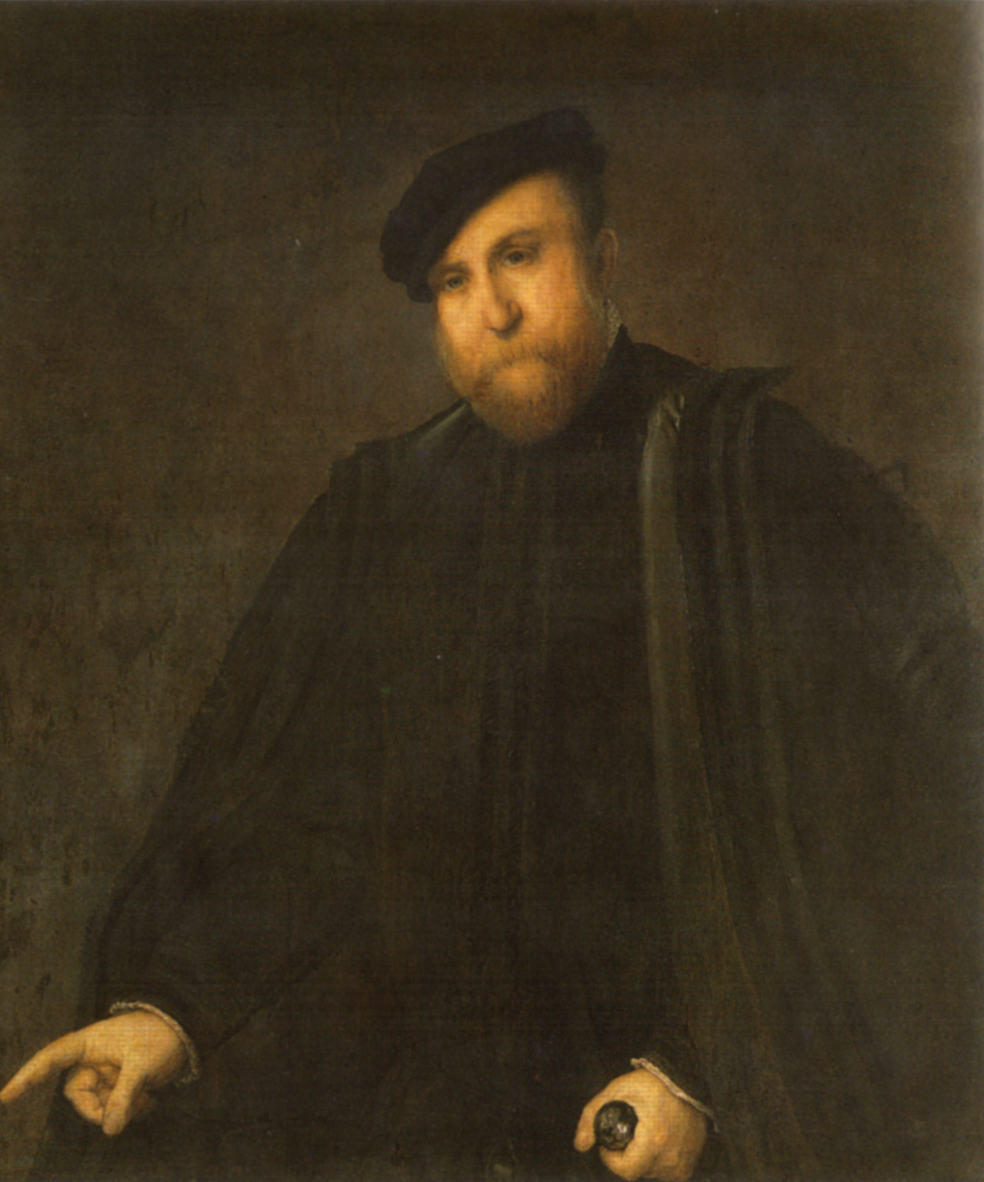Can you describe the main features of this image for me? The image presents a dignified portrait of a man, likely from the late 16th or early 17th century, based on the style of his clothing and the painting's overall aesthetic. He wears a dark, voluminous outfit with a wide collar and a matching hat, conveying an aura of authority and somber elegance. His expression is introspective and slightly stern, captured in a three-quarter view that brings depth to his persona. In one hand, he holds a pair of gloves, and in the other, a cane, both of which may symbolize his social status and sophistication. The background's muted brown tones focus attention on him, highlighting his face and hands, the central elements in this thoughtful composition. This portrait not only showcases the subject's prominent social standing but also hints at the complex human emotions, signifying a mastery of portrait artistry that transcends time. 